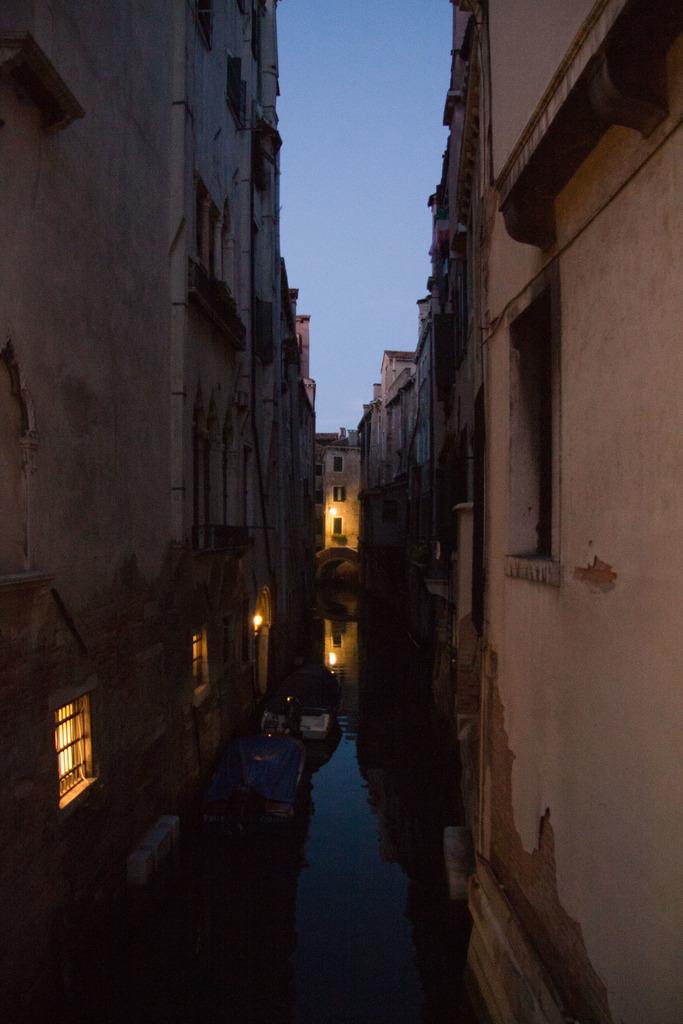Describe this image in one or two sentences. This image consists of many buildings. And we can see the lamps. At the bottom, there is water. At the top, there is sky. 